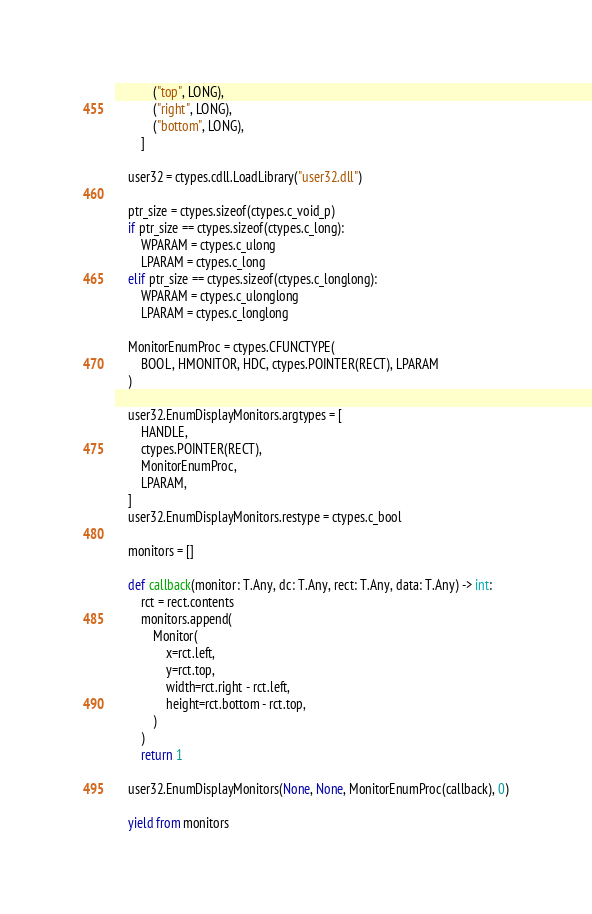Convert code to text. <code><loc_0><loc_0><loc_500><loc_500><_Python_>            ("top", LONG),
            ("right", LONG),
            ("bottom", LONG),
        ]

    user32 = ctypes.cdll.LoadLibrary("user32.dll")

    ptr_size = ctypes.sizeof(ctypes.c_void_p)
    if ptr_size == ctypes.sizeof(ctypes.c_long):
        WPARAM = ctypes.c_ulong
        LPARAM = ctypes.c_long
    elif ptr_size == ctypes.sizeof(ctypes.c_longlong):
        WPARAM = ctypes.c_ulonglong
        LPARAM = ctypes.c_longlong

    MonitorEnumProc = ctypes.CFUNCTYPE(
        BOOL, HMONITOR, HDC, ctypes.POINTER(RECT), LPARAM
    )

    user32.EnumDisplayMonitors.argtypes = [
        HANDLE,
        ctypes.POINTER(RECT),
        MonitorEnumProc,
        LPARAM,
    ]
    user32.EnumDisplayMonitors.restype = ctypes.c_bool

    monitors = []

    def callback(monitor: T.Any, dc: T.Any, rect: T.Any, data: T.Any) -> int:
        rct = rect.contents
        monitors.append(
            Monitor(
                x=rct.left,
                y=rct.top,
                width=rct.right - rct.left,
                height=rct.bottom - rct.top,
            )
        )
        return 1

    user32.EnumDisplayMonitors(None, None, MonitorEnumProc(callback), 0)

    yield from monitors
</code> 